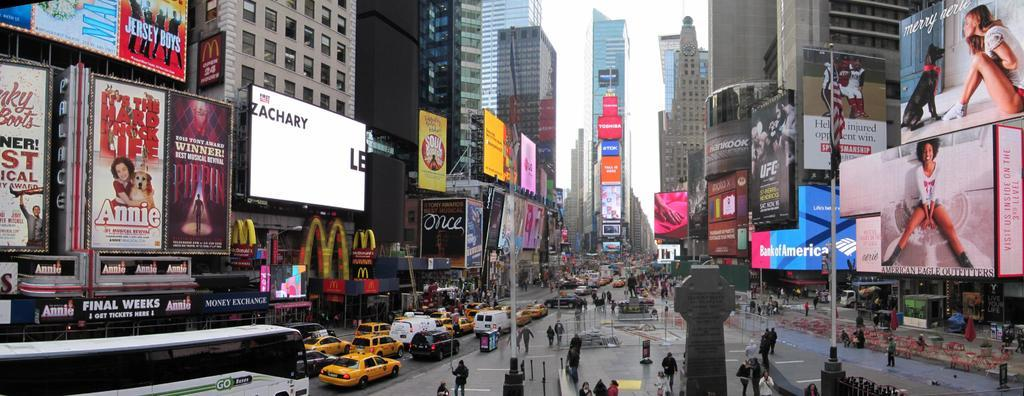<image>
Share a concise interpretation of the image provided. Rain is falling near the McDonalds in Times Square. 